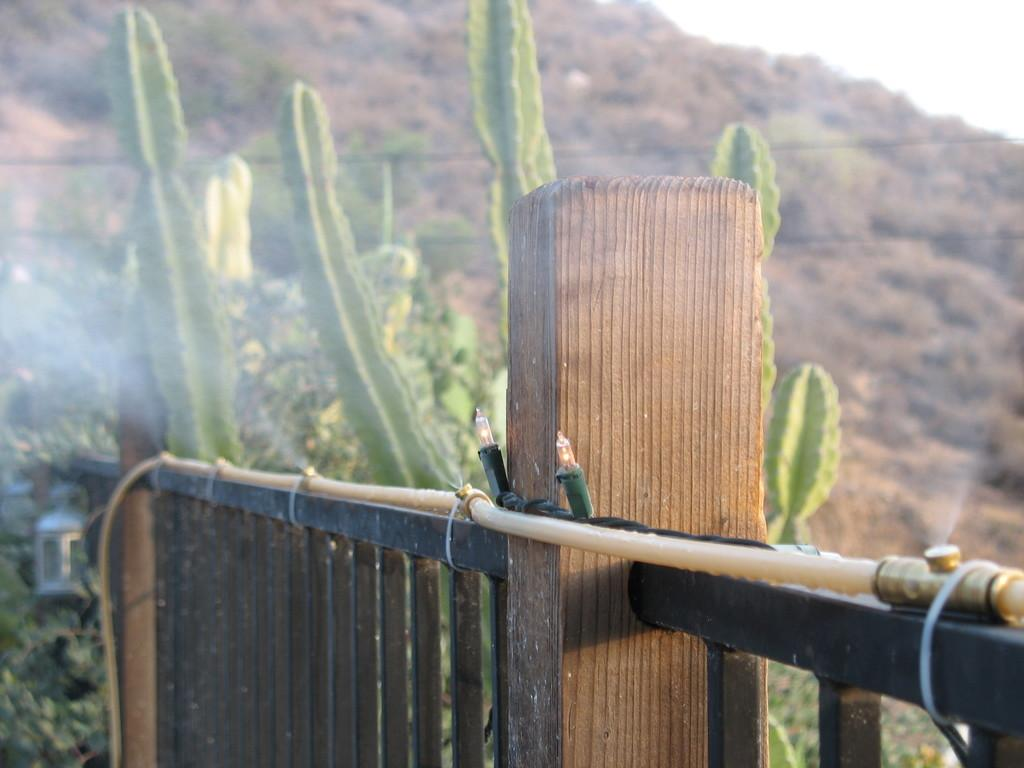What type of material is used for the railing in the image? The railing in the image is made of metal. What other structures can be seen in the image? There are wooden poles and a pipe visible in the image. What type of illumination is present in the image? There are lights in the image. What natural elements are present in the image? There are trees and a mountain in the image. What part of the natural environment is visible in the background of the image? The sky is visible in the background of the image. How many times does the person in the image sneeze? There is no person present in the image, so it is not possible to determine how many times they sneeze. What type of ice is used to create the mountain in the image? The mountain in the image is a natural formation and does not involve ice. 